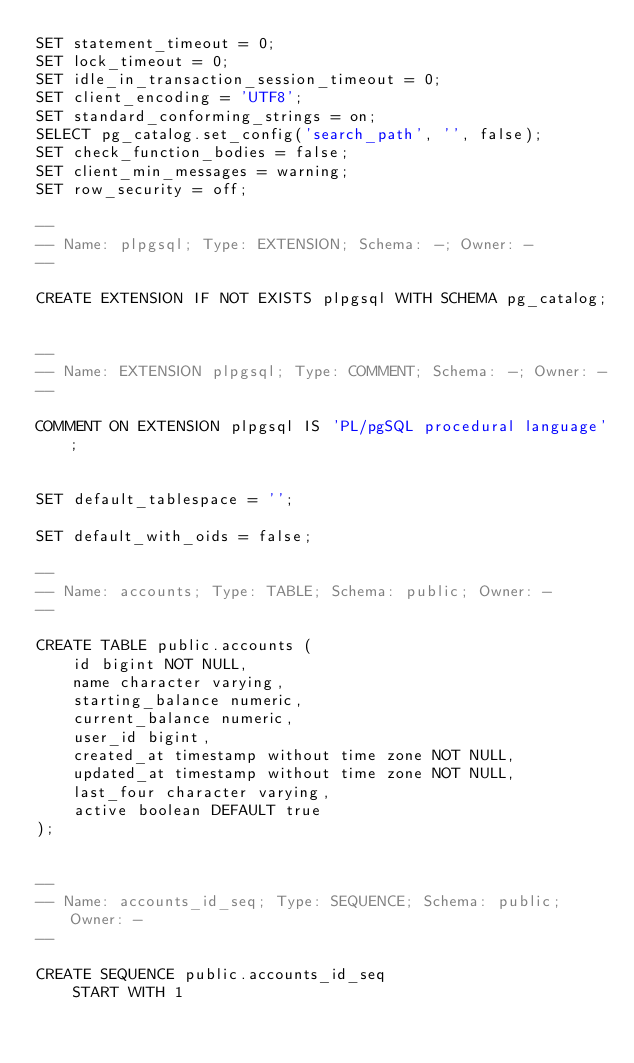Convert code to text. <code><loc_0><loc_0><loc_500><loc_500><_SQL_>SET statement_timeout = 0;
SET lock_timeout = 0;
SET idle_in_transaction_session_timeout = 0;
SET client_encoding = 'UTF8';
SET standard_conforming_strings = on;
SELECT pg_catalog.set_config('search_path', '', false);
SET check_function_bodies = false;
SET client_min_messages = warning;
SET row_security = off;

--
-- Name: plpgsql; Type: EXTENSION; Schema: -; Owner: -
--

CREATE EXTENSION IF NOT EXISTS plpgsql WITH SCHEMA pg_catalog;


--
-- Name: EXTENSION plpgsql; Type: COMMENT; Schema: -; Owner: -
--

COMMENT ON EXTENSION plpgsql IS 'PL/pgSQL procedural language';


SET default_tablespace = '';

SET default_with_oids = false;

--
-- Name: accounts; Type: TABLE; Schema: public; Owner: -
--

CREATE TABLE public.accounts (
    id bigint NOT NULL,
    name character varying,
    starting_balance numeric,
    current_balance numeric,
    user_id bigint,
    created_at timestamp without time zone NOT NULL,
    updated_at timestamp without time zone NOT NULL,
    last_four character varying,
    active boolean DEFAULT true
);


--
-- Name: accounts_id_seq; Type: SEQUENCE; Schema: public; Owner: -
--

CREATE SEQUENCE public.accounts_id_seq
    START WITH 1</code> 